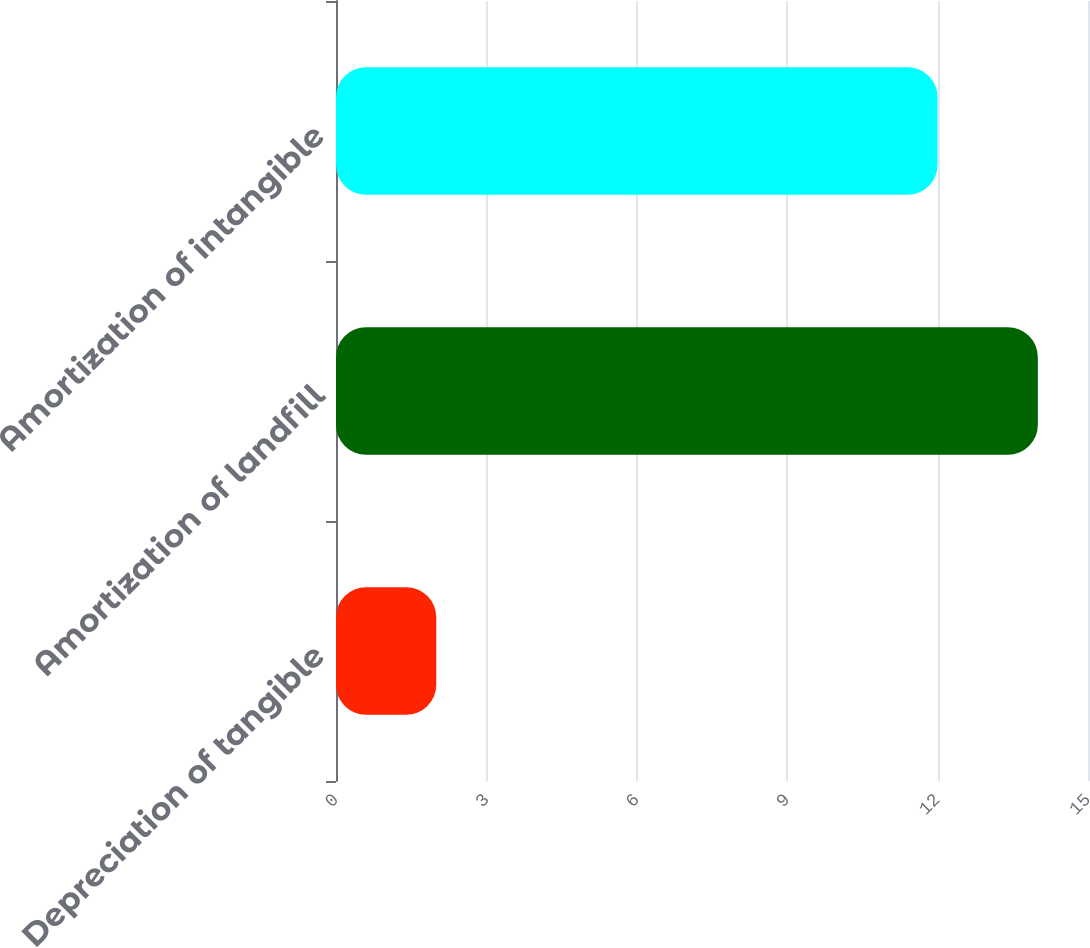Convert chart to OTSL. <chart><loc_0><loc_0><loc_500><loc_500><bar_chart><fcel>Depreciation of tangible<fcel>Amortization of landfill<fcel>Amortization of intangible<nl><fcel>2<fcel>14<fcel>12<nl></chart> 